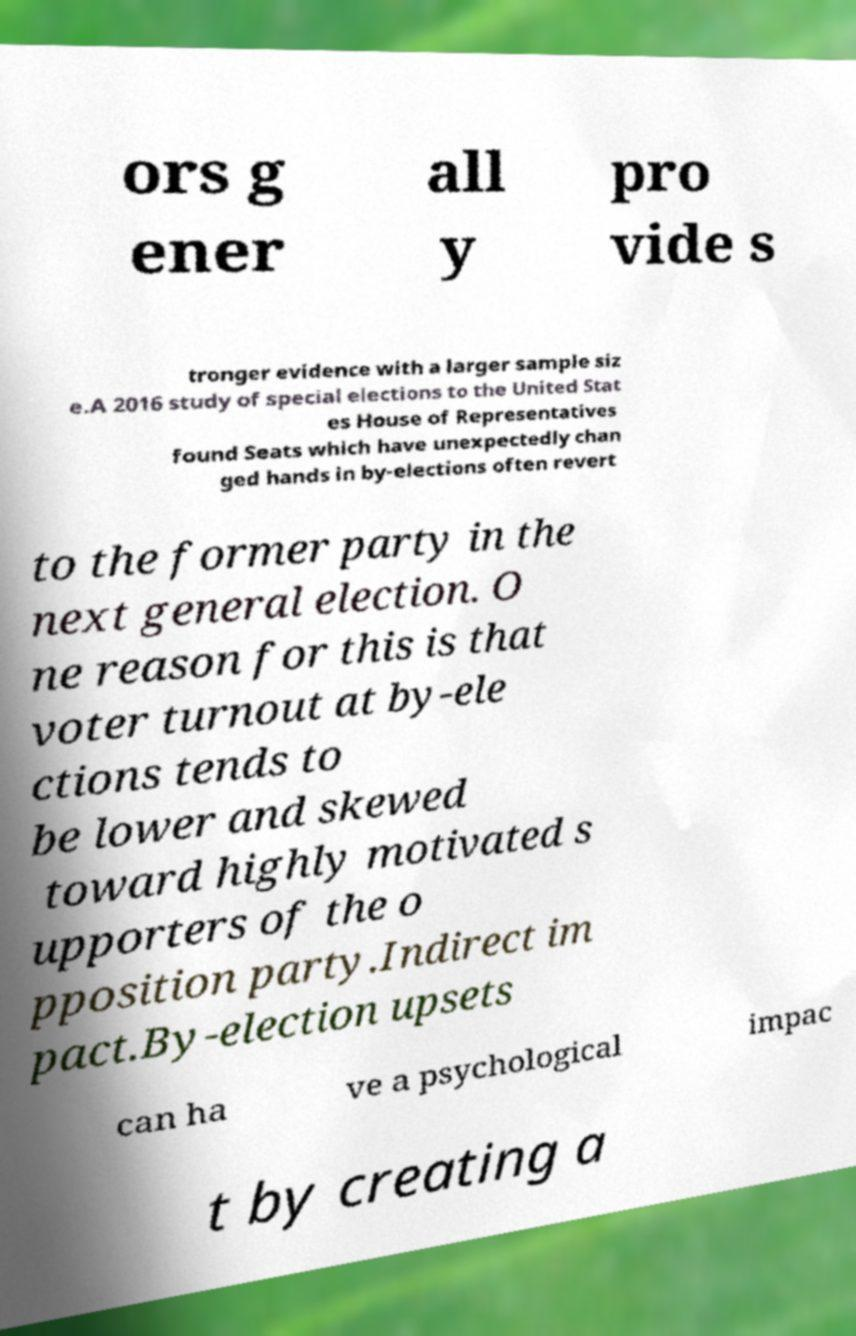What messages or text are displayed in this image? I need them in a readable, typed format. ors g ener all y pro vide s tronger evidence with a larger sample siz e.A 2016 study of special elections to the United Stat es House of Representatives found Seats which have unexpectedly chan ged hands in by-elections often revert to the former party in the next general election. O ne reason for this is that voter turnout at by-ele ctions tends to be lower and skewed toward highly motivated s upporters of the o pposition party.Indirect im pact.By-election upsets can ha ve a psychological impac t by creating a 